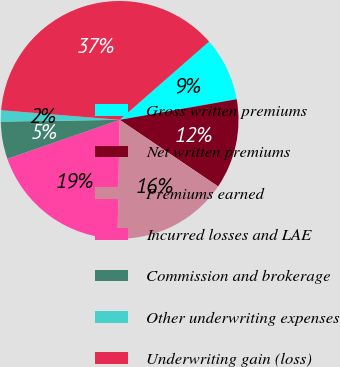Convert chart to OTSL. <chart><loc_0><loc_0><loc_500><loc_500><pie_chart><fcel>Gross written premiums<fcel>Net written premiums<fcel>Premiums earned<fcel>Incurred losses and LAE<fcel>Commission and brokerage<fcel>Other underwriting expenses<fcel>Underwriting gain (loss)<nl><fcel>8.67%<fcel>12.24%<fcel>15.82%<fcel>19.39%<fcel>5.09%<fcel>1.52%<fcel>37.27%<nl></chart> 